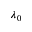Convert formula to latex. <formula><loc_0><loc_0><loc_500><loc_500>\lambda _ { 0 }</formula> 